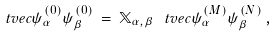Convert formula to latex. <formula><loc_0><loc_0><loc_500><loc_500>\ t v e c { \psi _ { \alpha } ^ { ( 0 ) } } { \psi _ { \beta } ^ { ( 0 ) } } \, = \, \mathbb { X } _ { \alpha , \beta } \, \ t v e c { \psi _ { \alpha } ^ { ( M ) } } { \psi _ { \beta } ^ { ( N ) } } \, ,</formula> 